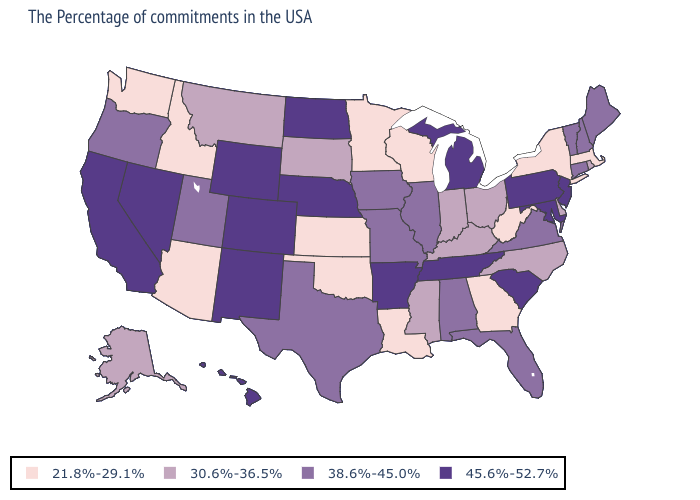Which states have the highest value in the USA?
Write a very short answer. New Jersey, Maryland, Pennsylvania, South Carolina, Michigan, Tennessee, Arkansas, Nebraska, North Dakota, Wyoming, Colorado, New Mexico, Nevada, California, Hawaii. What is the highest value in the USA?
Be succinct. 45.6%-52.7%. Among the states that border Florida , does Alabama have the highest value?
Concise answer only. Yes. What is the value of California?
Answer briefly. 45.6%-52.7%. Does New Jersey have the same value as Nevada?
Write a very short answer. Yes. Does Washington have the same value as Tennessee?
Concise answer only. No. Which states have the lowest value in the South?
Quick response, please. West Virginia, Georgia, Louisiana, Oklahoma. What is the value of Tennessee?
Be succinct. 45.6%-52.7%. Name the states that have a value in the range 21.8%-29.1%?
Be succinct. Massachusetts, New York, West Virginia, Georgia, Wisconsin, Louisiana, Minnesota, Kansas, Oklahoma, Arizona, Idaho, Washington. Among the states that border North Dakota , which have the highest value?
Answer briefly. South Dakota, Montana. What is the value of Mississippi?
Quick response, please. 30.6%-36.5%. Does Minnesota have the highest value in the MidWest?
Write a very short answer. No. What is the lowest value in the Northeast?
Concise answer only. 21.8%-29.1%. Among the states that border Georgia , which have the highest value?
Keep it brief. South Carolina, Tennessee. Does the first symbol in the legend represent the smallest category?
Be succinct. Yes. 